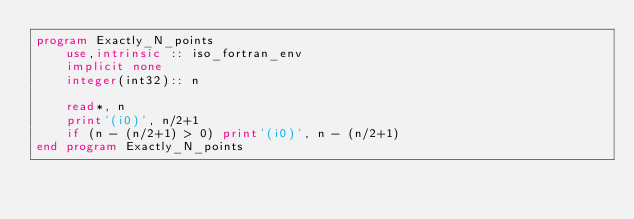<code> <loc_0><loc_0><loc_500><loc_500><_FORTRAN_>program Exactly_N_points
    use,intrinsic :: iso_fortran_env
    implicit none
    integer(int32):: n

    read*, n
    print'(i0)', n/2+1
    if (n - (n/2+1) > 0) print'(i0)', n - (n/2+1)
end program Exactly_N_points</code> 